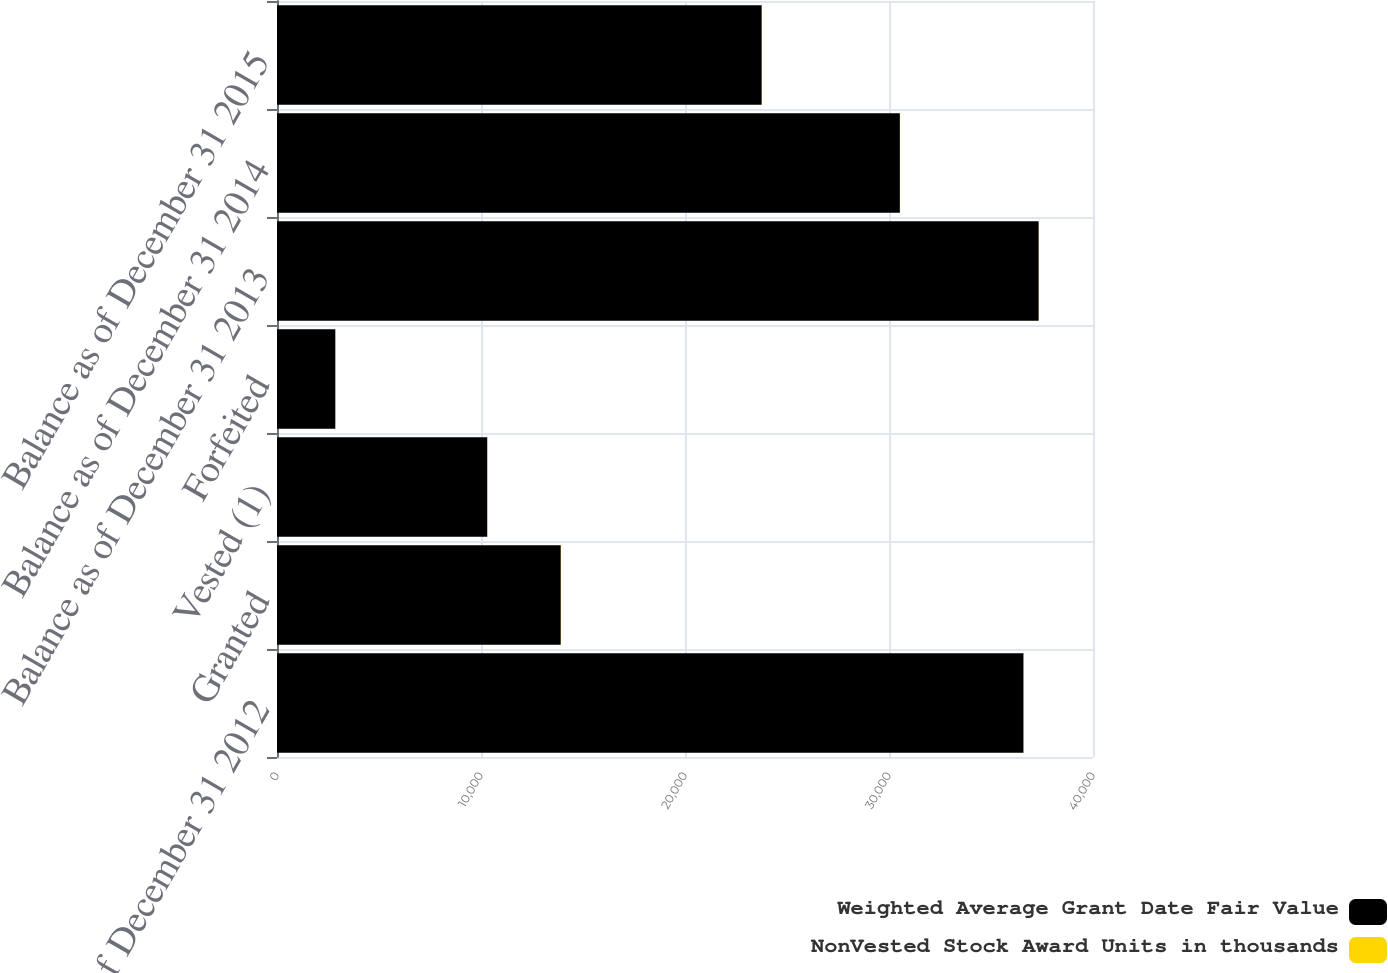Convert chart. <chart><loc_0><loc_0><loc_500><loc_500><stacked_bar_chart><ecel><fcel>Balance as of December 31 2012<fcel>Granted<fcel>Vested (1)<fcel>Forfeited<fcel>Balance as of December 31 2013<fcel>Balance as of December 31 2014<fcel>Balance as of December 31 2015<nl><fcel>Weighted Average Grant Date Fair Value<fcel>36593<fcel>13913<fcel>10307<fcel>2860<fcel>37339<fcel>30535<fcel>23764<nl><fcel>NonVested Stock Award Units in thousands<fcel>7<fcel>8<fcel>8<fcel>7<fcel>7<fcel>9<fcel>11<nl></chart> 